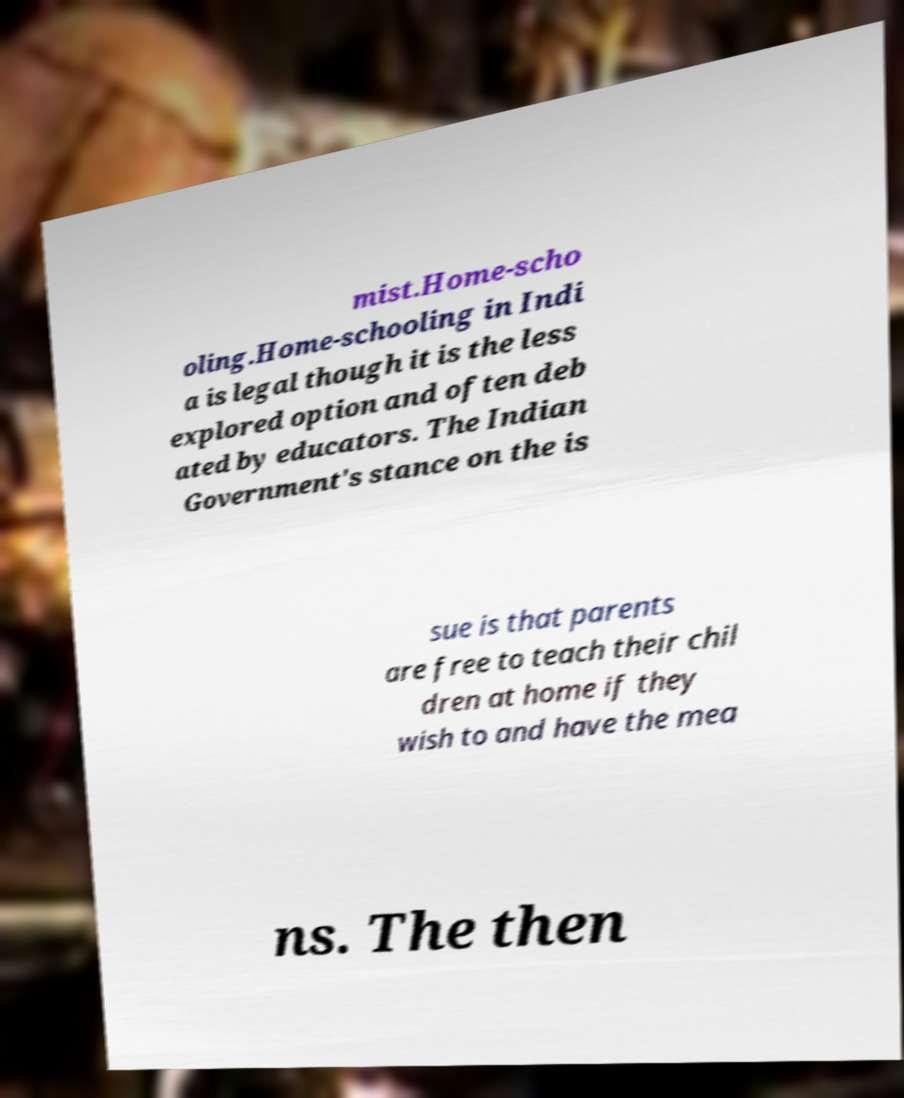What messages or text are displayed in this image? I need them in a readable, typed format. mist.Home-scho oling.Home-schooling in Indi a is legal though it is the less explored option and often deb ated by educators. The Indian Government's stance on the is sue is that parents are free to teach their chil dren at home if they wish to and have the mea ns. The then 